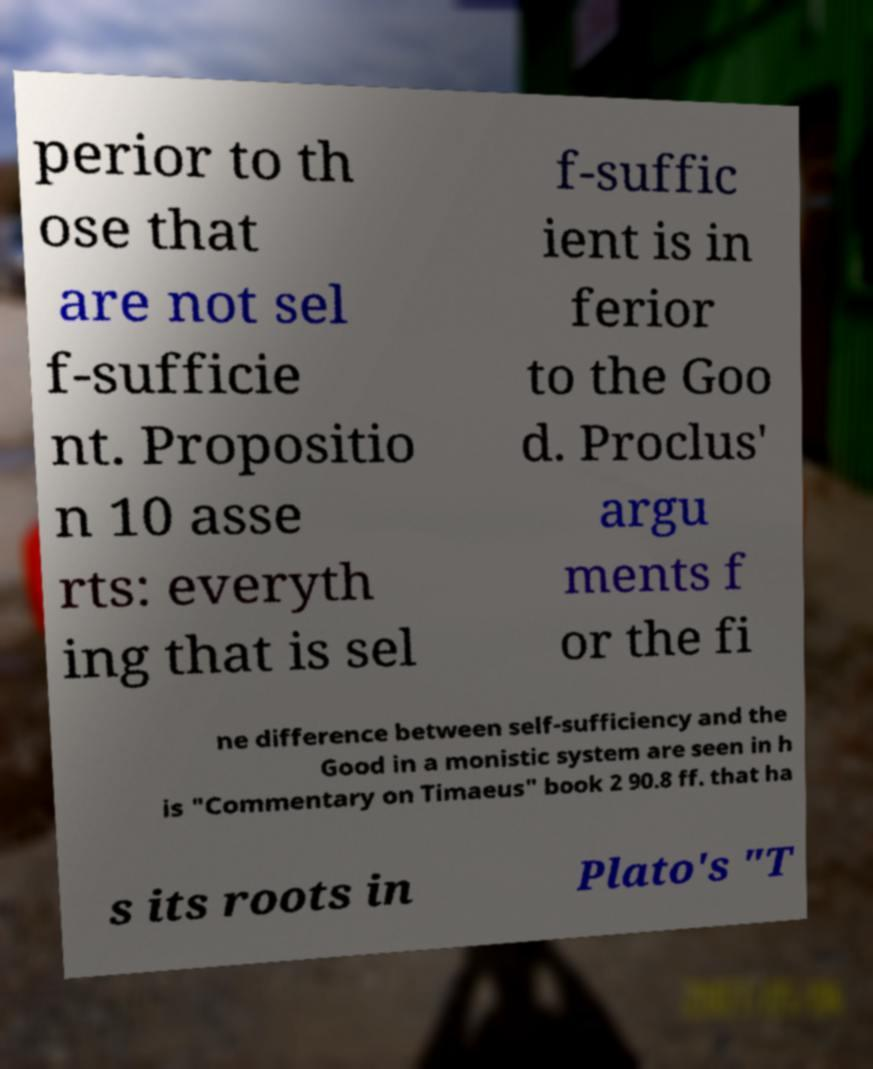Please read and relay the text visible in this image. What does it say? perior to th ose that are not sel f-sufficie nt. Propositio n 10 asse rts: everyth ing that is sel f-suffic ient is in ferior to the Goo d. Proclus' argu ments f or the fi ne difference between self-sufficiency and the Good in a monistic system are seen in h is "Commentary on Timaeus" book 2 90.8 ff. that ha s its roots in Plato's "T 